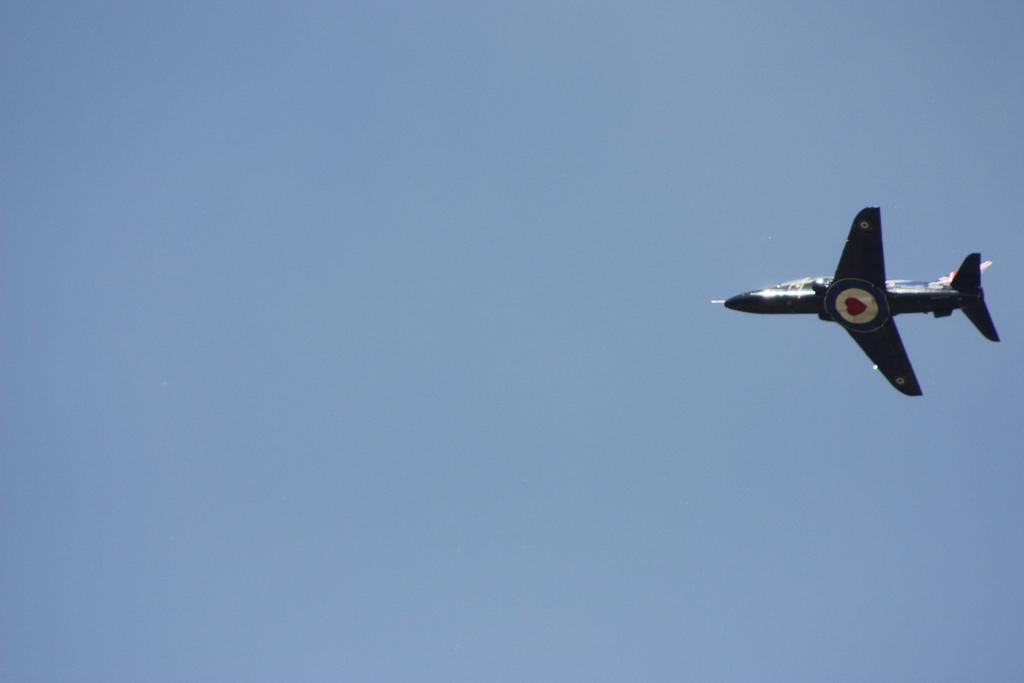Please provide a concise description of this image. In this image, we can see an aeroplane in the sky. 